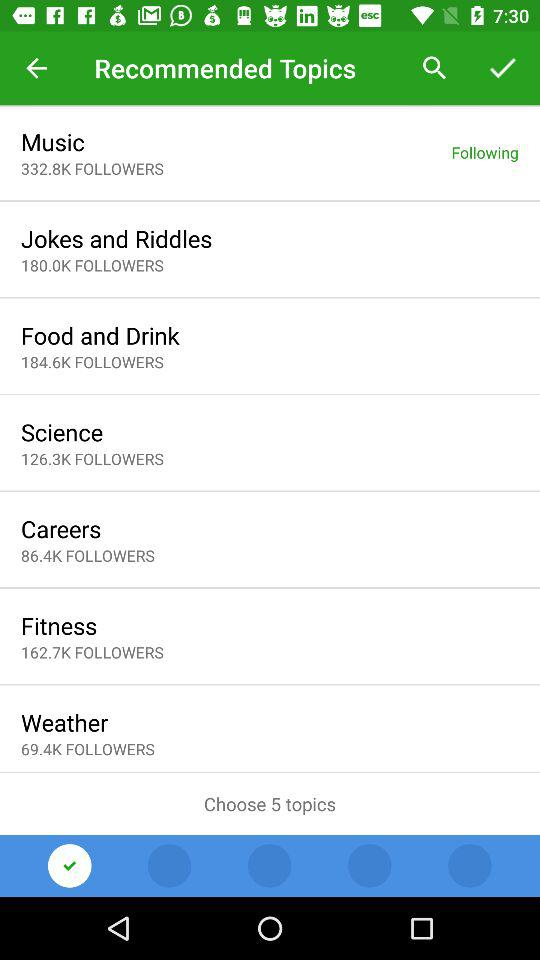What's the total number of followers of "Science"? The total number of followers is 126.3K. 